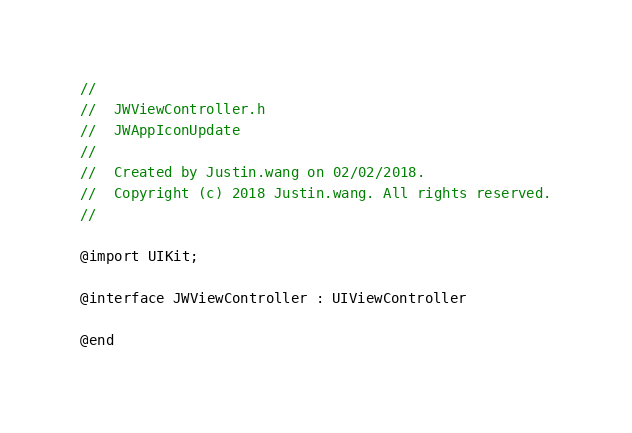<code> <loc_0><loc_0><loc_500><loc_500><_C_>//
//  JWViewController.h
//  JWAppIconUpdate
//
//  Created by Justin.wang on 02/02/2018.
//  Copyright (c) 2018 Justin.wang. All rights reserved.
//

@import UIKit;

@interface JWViewController : UIViewController

@end
</code> 